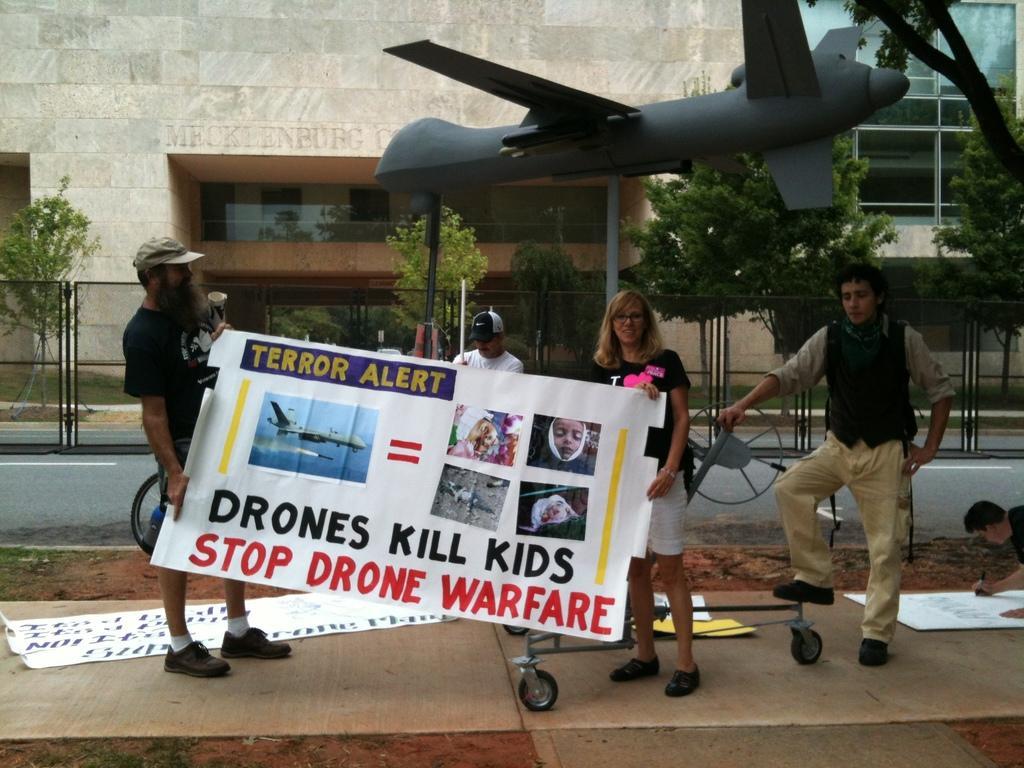Please provide a concise description of this image. In this image there are group of people, two people standing and holding a banner, papers on the path, demo airplane, buildings, trees. 